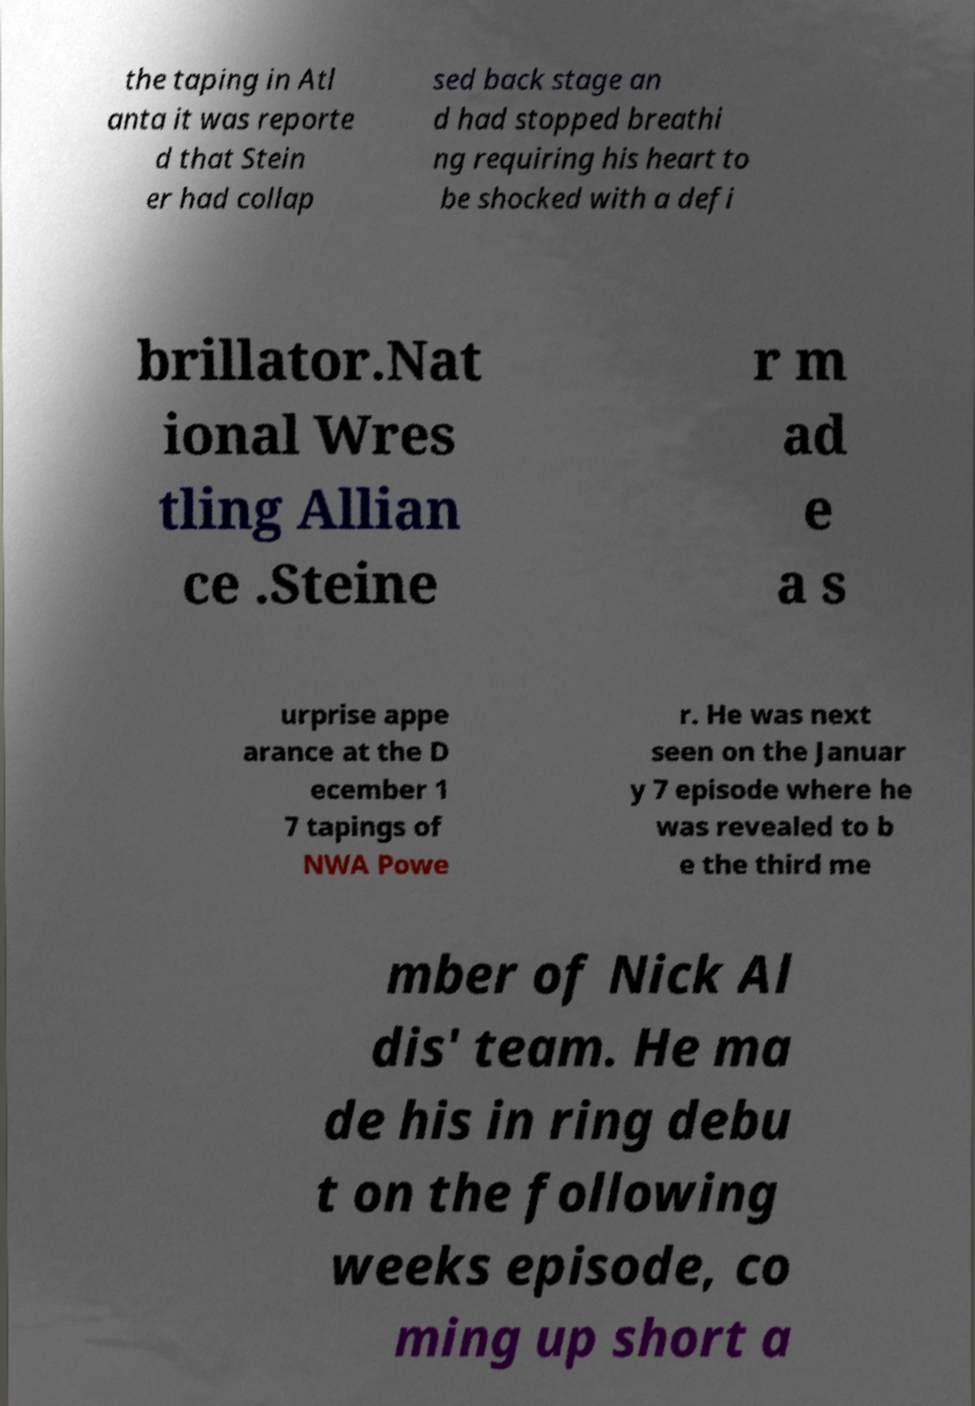Can you accurately transcribe the text from the provided image for me? the taping in Atl anta it was reporte d that Stein er had collap sed back stage an d had stopped breathi ng requiring his heart to be shocked with a defi brillator.Nat ional Wres tling Allian ce .Steine r m ad e a s urprise appe arance at the D ecember 1 7 tapings of NWA Powe r. He was next seen on the Januar y 7 episode where he was revealed to b e the third me mber of Nick Al dis' team. He ma de his in ring debu t on the following weeks episode, co ming up short a 